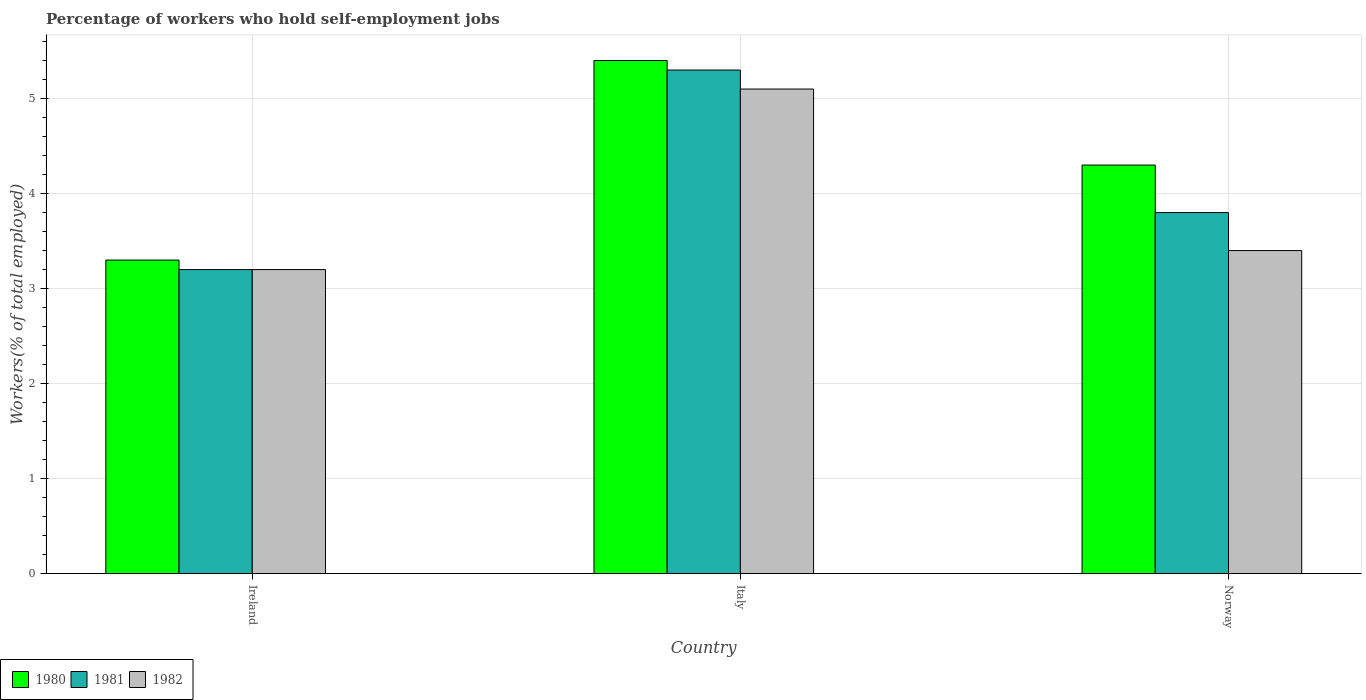How many different coloured bars are there?
Make the answer very short. 3. Are the number of bars on each tick of the X-axis equal?
Your response must be concise. Yes. How many bars are there on the 3rd tick from the right?
Provide a short and direct response. 3. What is the label of the 2nd group of bars from the left?
Keep it short and to the point. Italy. What is the percentage of self-employed workers in 1981 in Ireland?
Provide a succinct answer. 3.2. Across all countries, what is the maximum percentage of self-employed workers in 1982?
Provide a succinct answer. 5.1. Across all countries, what is the minimum percentage of self-employed workers in 1982?
Provide a succinct answer. 3.2. In which country was the percentage of self-employed workers in 1982 maximum?
Your answer should be compact. Italy. In which country was the percentage of self-employed workers in 1981 minimum?
Keep it short and to the point. Ireland. What is the total percentage of self-employed workers in 1980 in the graph?
Offer a very short reply. 13. What is the difference between the percentage of self-employed workers in 1981 in Ireland and that in Norway?
Provide a short and direct response. -0.6. What is the difference between the percentage of self-employed workers in 1982 in Ireland and the percentage of self-employed workers in 1980 in Italy?
Your response must be concise. -2.2. What is the average percentage of self-employed workers in 1981 per country?
Offer a very short reply. 4.1. What is the difference between the percentage of self-employed workers of/in 1980 and percentage of self-employed workers of/in 1981 in Norway?
Offer a very short reply. 0.5. In how many countries, is the percentage of self-employed workers in 1980 greater than 3 %?
Make the answer very short. 3. What is the ratio of the percentage of self-employed workers in 1980 in Italy to that in Norway?
Make the answer very short. 1.26. Is the percentage of self-employed workers in 1981 in Ireland less than that in Norway?
Offer a terse response. Yes. Is the difference between the percentage of self-employed workers in 1980 in Ireland and Norway greater than the difference between the percentage of self-employed workers in 1981 in Ireland and Norway?
Your answer should be compact. No. What is the difference between the highest and the second highest percentage of self-employed workers in 1981?
Offer a terse response. -0.6. What is the difference between the highest and the lowest percentage of self-employed workers in 1982?
Your response must be concise. 1.9. What does the 2nd bar from the left in Ireland represents?
Keep it short and to the point. 1981. Are all the bars in the graph horizontal?
Your answer should be very brief. No. How many countries are there in the graph?
Provide a short and direct response. 3. What is the difference between two consecutive major ticks on the Y-axis?
Your answer should be compact. 1. Does the graph contain any zero values?
Provide a short and direct response. No. Does the graph contain grids?
Your answer should be compact. Yes. Where does the legend appear in the graph?
Ensure brevity in your answer.  Bottom left. How many legend labels are there?
Provide a succinct answer. 3. What is the title of the graph?
Give a very brief answer. Percentage of workers who hold self-employment jobs. What is the label or title of the Y-axis?
Provide a short and direct response. Workers(% of total employed). What is the Workers(% of total employed) of 1980 in Ireland?
Your answer should be very brief. 3.3. What is the Workers(% of total employed) of 1981 in Ireland?
Offer a terse response. 3.2. What is the Workers(% of total employed) in 1982 in Ireland?
Keep it short and to the point. 3.2. What is the Workers(% of total employed) in 1980 in Italy?
Your answer should be very brief. 5.4. What is the Workers(% of total employed) in 1981 in Italy?
Your response must be concise. 5.3. What is the Workers(% of total employed) in 1982 in Italy?
Provide a short and direct response. 5.1. What is the Workers(% of total employed) in 1980 in Norway?
Provide a short and direct response. 4.3. What is the Workers(% of total employed) in 1981 in Norway?
Make the answer very short. 3.8. What is the Workers(% of total employed) of 1982 in Norway?
Provide a short and direct response. 3.4. Across all countries, what is the maximum Workers(% of total employed) of 1980?
Provide a succinct answer. 5.4. Across all countries, what is the maximum Workers(% of total employed) of 1981?
Your answer should be very brief. 5.3. Across all countries, what is the maximum Workers(% of total employed) in 1982?
Your answer should be compact. 5.1. Across all countries, what is the minimum Workers(% of total employed) in 1980?
Offer a very short reply. 3.3. Across all countries, what is the minimum Workers(% of total employed) of 1981?
Your answer should be very brief. 3.2. Across all countries, what is the minimum Workers(% of total employed) of 1982?
Make the answer very short. 3.2. What is the total Workers(% of total employed) of 1980 in the graph?
Provide a short and direct response. 13. What is the total Workers(% of total employed) of 1981 in the graph?
Provide a short and direct response. 12.3. What is the total Workers(% of total employed) of 1982 in the graph?
Offer a terse response. 11.7. What is the difference between the Workers(% of total employed) in 1980 in Ireland and that in Italy?
Your response must be concise. -2.1. What is the difference between the Workers(% of total employed) in 1981 in Ireland and that in Italy?
Your response must be concise. -2.1. What is the difference between the Workers(% of total employed) in 1982 in Ireland and that in Norway?
Provide a succinct answer. -0.2. What is the difference between the Workers(% of total employed) in 1981 in Italy and that in Norway?
Provide a succinct answer. 1.5. What is the difference between the Workers(% of total employed) of 1982 in Italy and that in Norway?
Provide a short and direct response. 1.7. What is the difference between the Workers(% of total employed) of 1980 in Ireland and the Workers(% of total employed) of 1982 in Italy?
Your answer should be compact. -1.8. What is the difference between the Workers(% of total employed) in 1981 in Ireland and the Workers(% of total employed) in 1982 in Italy?
Offer a very short reply. -1.9. What is the difference between the Workers(% of total employed) in 1980 in Italy and the Workers(% of total employed) in 1981 in Norway?
Give a very brief answer. 1.6. What is the difference between the Workers(% of total employed) of 1981 in Italy and the Workers(% of total employed) of 1982 in Norway?
Your answer should be very brief. 1.9. What is the average Workers(% of total employed) in 1980 per country?
Give a very brief answer. 4.33. What is the average Workers(% of total employed) of 1981 per country?
Your response must be concise. 4.1. What is the difference between the Workers(% of total employed) of 1980 and Workers(% of total employed) of 1981 in Ireland?
Offer a terse response. 0.1. What is the difference between the Workers(% of total employed) of 1980 and Workers(% of total employed) of 1982 in Ireland?
Provide a succinct answer. 0.1. What is the difference between the Workers(% of total employed) of 1980 and Workers(% of total employed) of 1982 in Italy?
Make the answer very short. 0.3. What is the difference between the Workers(% of total employed) of 1981 and Workers(% of total employed) of 1982 in Norway?
Give a very brief answer. 0.4. What is the ratio of the Workers(% of total employed) in 1980 in Ireland to that in Italy?
Give a very brief answer. 0.61. What is the ratio of the Workers(% of total employed) of 1981 in Ireland to that in Italy?
Make the answer very short. 0.6. What is the ratio of the Workers(% of total employed) in 1982 in Ireland to that in Italy?
Provide a short and direct response. 0.63. What is the ratio of the Workers(% of total employed) in 1980 in Ireland to that in Norway?
Keep it short and to the point. 0.77. What is the ratio of the Workers(% of total employed) in 1981 in Ireland to that in Norway?
Your response must be concise. 0.84. What is the ratio of the Workers(% of total employed) in 1980 in Italy to that in Norway?
Offer a terse response. 1.26. What is the ratio of the Workers(% of total employed) in 1981 in Italy to that in Norway?
Keep it short and to the point. 1.39. What is the difference between the highest and the second highest Workers(% of total employed) in 1981?
Keep it short and to the point. 1.5. What is the difference between the highest and the lowest Workers(% of total employed) in 1980?
Keep it short and to the point. 2.1. 